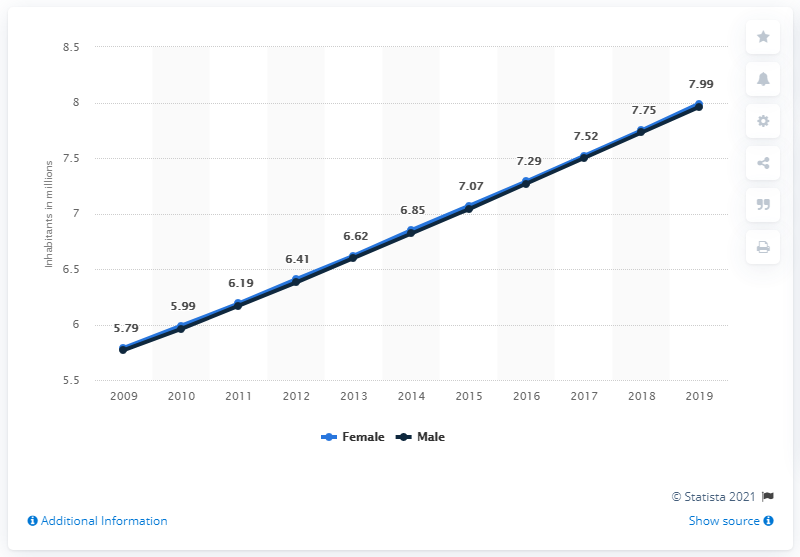Outline some significant characteristics in this image. The female population of Chad in 2019 was estimated to be approximately 7.99 million. 